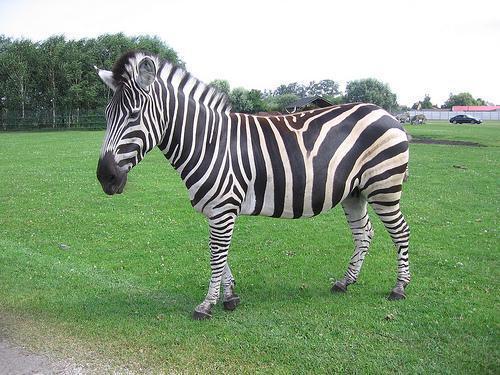How many zebras are there?
Give a very brief answer. 1. 